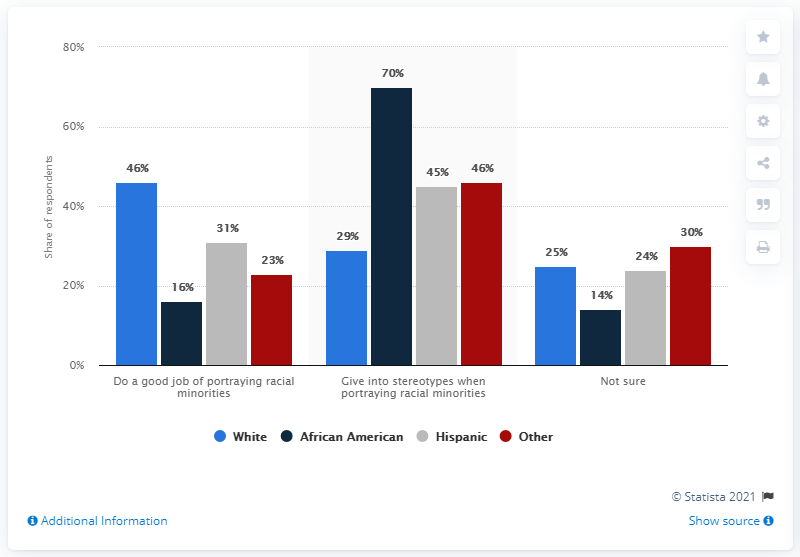List a handful of essential elements in this visual. The given sentence is a question that is asking about a race that is indicated in gray color in a graph. The sentence is asking for information about the race that is indicated in gray color in the graph. According to a recent survey, a majority of people, or 116%, believe that Hollywood does an excellent job of portraying racial minorities. 